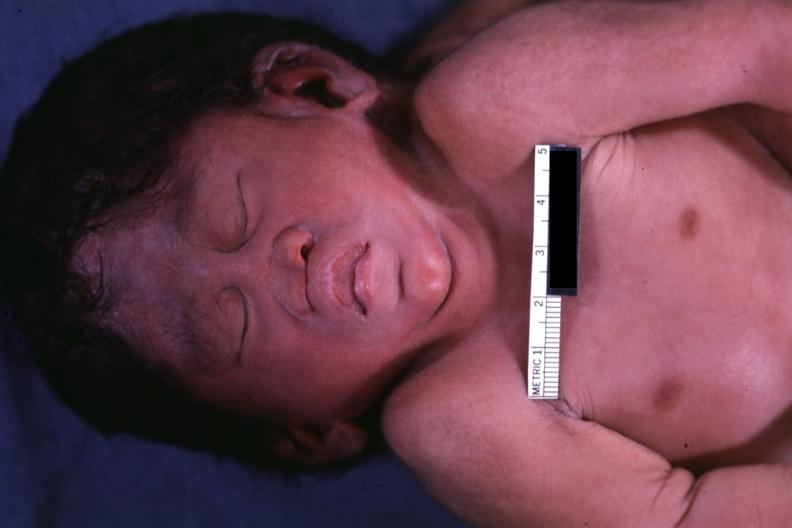what does this image show?
Answer the question using a single word or phrase. Close-up view of head anterior view 